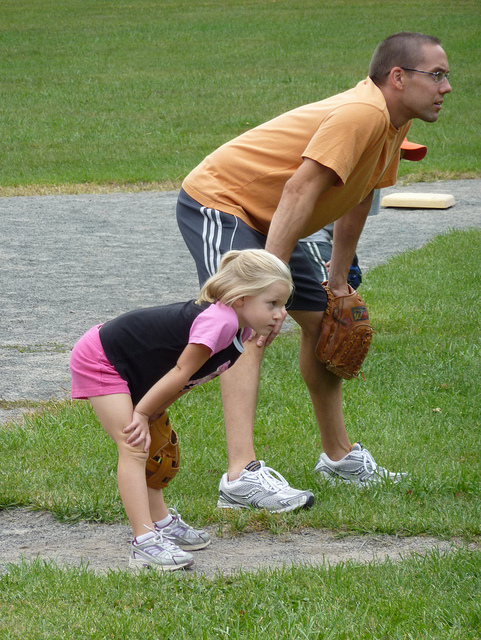Can you tell me something about the outfits they are wearing? Certainly! The adult is wearing a short-sleeved, orange t-shirt paired with dark athletic shorts, along with sneakers suitable for outdoor activity. The child is wearing a black t-shirt, pink shorts, and athletic shoes, which altogether is appropriate attire for playing outdoors and being active. 